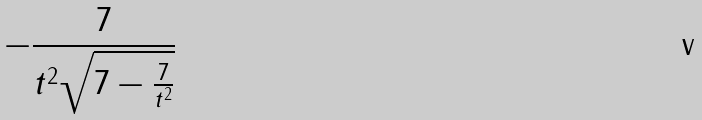Convert formula to latex. <formula><loc_0><loc_0><loc_500><loc_500>- \frac { 7 } { t ^ { 2 } \sqrt { 7 - \frac { 7 } { t ^ { 2 } } } }</formula> 